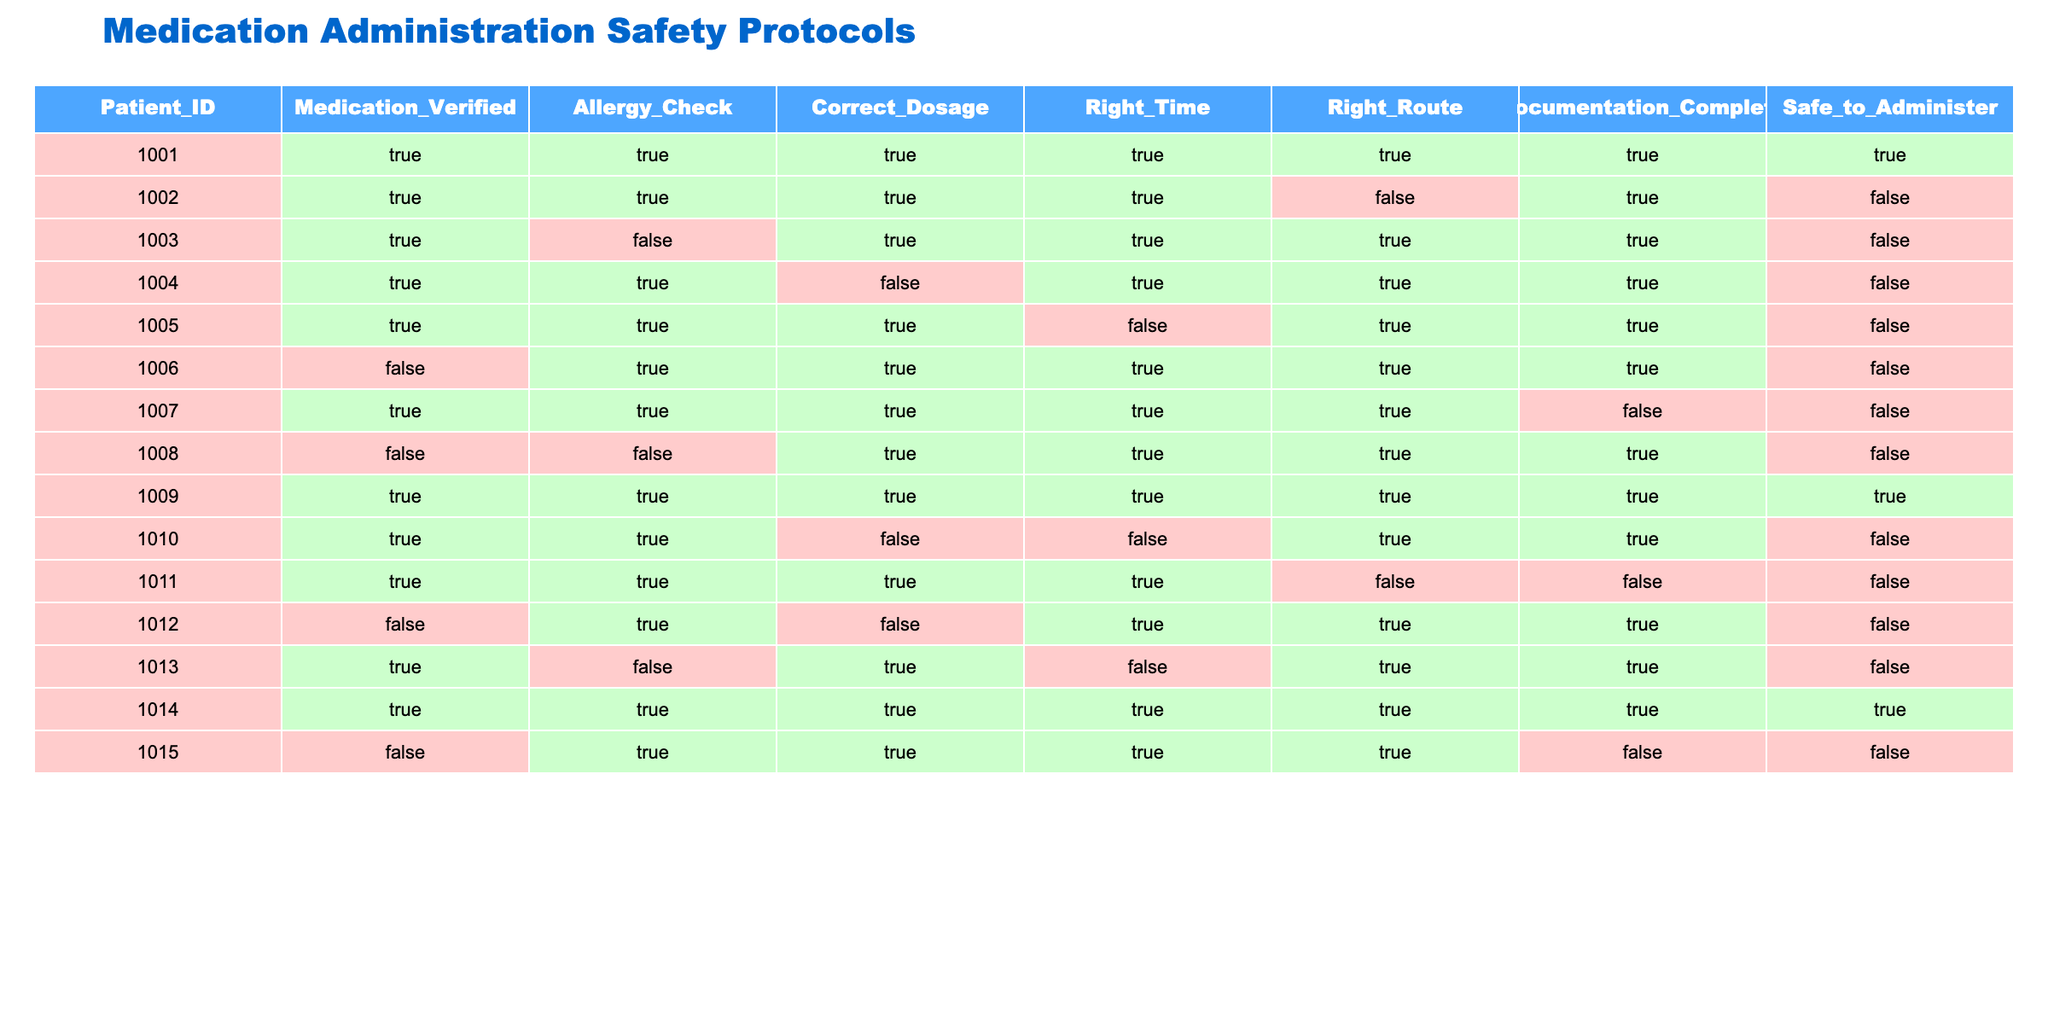What is the patient ID for the safest medication administration? The safest medication administration is indicated by the "Safe_to_Administer" column, which is TRUE for only one patient. By looking at the table, patient ID 1009 has "TRUE" in the "Safe_to_Administer" column.
Answer: 1009 How many patients had their medication administered safely? By referencing the "Safe_to_Administer" column, we can count how many rows have "TRUE." From the table, there are only two instances (patient IDs 1009 and 1014).
Answer: 2 Is there any patient who was given medication without verifying it? We can look at the "Medication_Verified" column and check for any "FALSE" entries. Patient IDs 1006, 1008, 1012, and 1015 have "FALSE," indicating they did not have verification before administration.
Answer: Yes Which patient ID had all criteria met except for the right route? We examine the combination of columns for a row where all criteria have "TRUE" except the "Right_Route." Patient ID 1010 has "FALSE" in "Right_Time" and "Right_Route," so it does not qualify. Instead, we find that patient ID 1004 had "FALSE" in "Correct_Dosage."
Answer: 1004 What is the total number of patients who did not have their documentation complete? To find the total, we count how many rows have "FALSE" in the "Documentation_Complete" column. Checking the table shows there are four patients with incomplete documentation.
Answer: 4 Are there any patients who had a correct dosage but had not been checked for allergies? We check the "Correct_Dosage" for "TRUE" and find the "Allergy_Check" was "FALSE." Patient ID 1013 has "TRUE" for dosage but "FALSE" for allergies check.
Answer: Yes What proportion of patients had a medication administration that was safe compared to the total number of patients? The total number of patients is 15. There are 2 patients with a safe medication administration (IDs 1009 and 1014). Thus, the proportion is calculated as 2/15, which simplifies to approximately 0.13 or 13%.
Answer: 13% How many patients had correct dosages and right routes? For this, we count the number of patients who have "TRUE" in both "Correct_Dosage" and "Right_Route." By referencing the table, there are 7 patients who had both conditions met.
Answer: 7 Can you name any individual patient who failed the allergy check? Looking at the "Allergy_Check" column, we can check which patient IDs had "FALSE." The patient IDs that failed the allergy check are 1003, 1008, 1012, and 1015.
Answer: 1003, 1008, 1012, 1015 